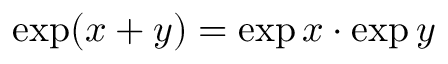Convert formula to latex. <formula><loc_0><loc_0><loc_500><loc_500>\exp ( x + y ) = \exp x \cdot \exp y</formula> 